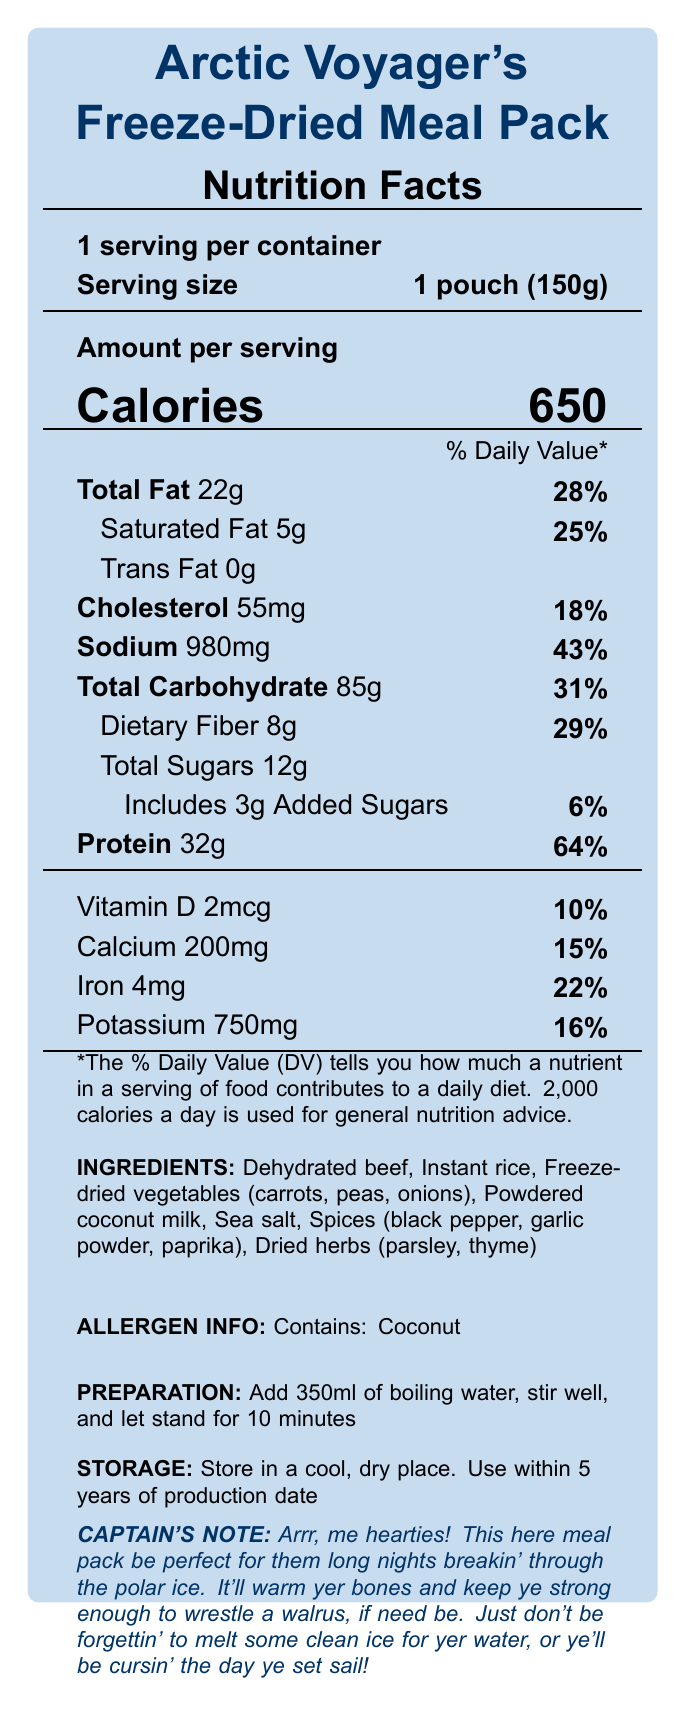what is the serving size? The document specifies the serving size as "1 pouch (150g)" on the Nutrition Facts label.
Answer: 1 pouch (150g) how many calories are in one serving of this meal pack? The document states that one serving contains 650 calories.
Answer: 650 what is the total amount of fat in a serving? The Nutrition Facts label shows that total fat per serving is 22g.
Answer: 22g how much dietary fiber does the meal pack provide? The document indicates that the meal pack contains 8g of dietary fiber.
Answer: 8g what is the recommended preparation method for this meal pack? The preparation instructions state: "Add 350ml of boiling water, stir well, and let stand for 10 minutes."
Answer: Add 350ml of boiling water, stir well, and let stand for 10 minutes which of the following ingredients can be found in the meal pack? A. Freeze-dried chicken B. Freeze-dried vegetables C. Dried fruits D. Instant potatoes The document lists ingredients including freeze-dried vegetables (carrots, peas, onions).
Answer: B what is the daily value percentage for protein in this meal pack? A. 25% B. 64% C. 43% D. 10% The document shows that the daily value percentage for protein is 64%.
Answer: B does this meal pack contain added sugars? The Nutrition Facts label includes "Adds 3g Added Sugars" indicating that there are added sugars.
Answer: Yes does the meal pack contain any allergens? The allergen info section of the document states that it contains coconut.
Answer: Yes summarize the main purpose of this document. The document serves to inform consumers about the nutritional content, how to prepare, and store the meal pack, and highlights its benefit for long polar voyages with an anecdotal note from the captain.
Answer: The document provides detailed nutritional information, ingredients, allergen warnings, preparation instructions, storage guidelines, and a promotional note for the Arctic Voyager's Freeze-Dried Meal Pack, which is designed to provide nutrition during polar expeditions. what is the exact amount of potassium in the meal pack? The document lists potassium content as 750mg.
Answer: 750mg how many grams of saturated fat are in one serving of this meal pack? The document specifies that one serving contains 5g of saturated fat.
Answer: 5g is there any trans fat in this meal pack? The Nutrition Facts label lists trans fat as 0g, indicating there is no trans fat.
Answer: No what percentage of daily value does dietary fiber account for? The document shows that dietary fiber makes up 29% of the daily value.
Answer: 29% what other products are offered by the same manufacturer? The document only provides information about the Arctic Voyager's Freeze-Dried Meal Pack, with no mention of other products.
Answer: Not enough information 